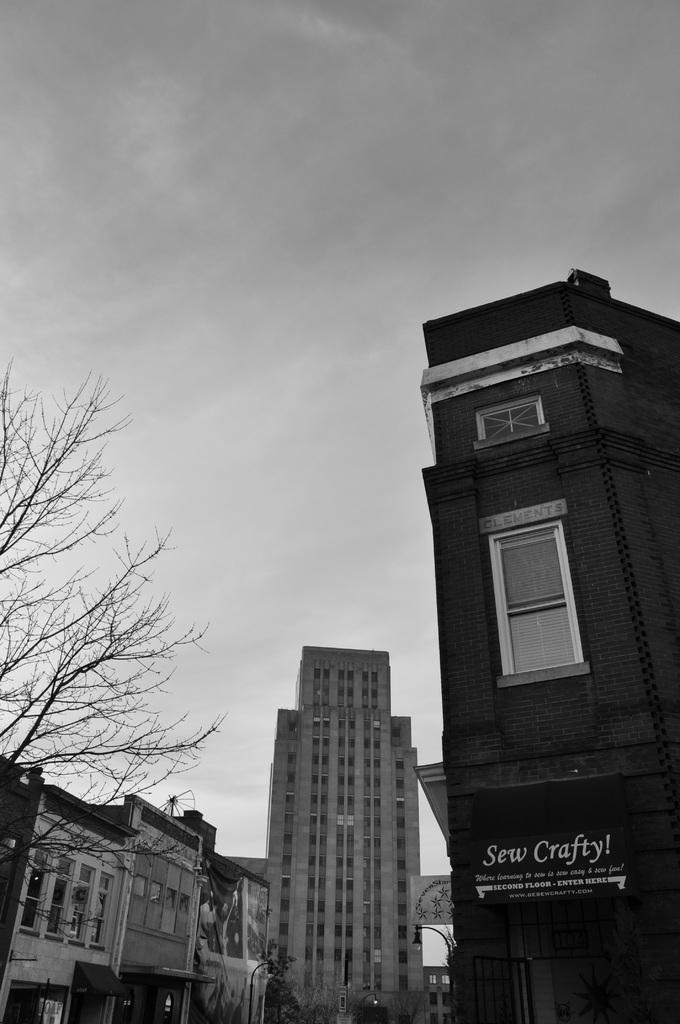How would you summarize this image in a sentence or two? In this image there are buildings, trees and the sky. 